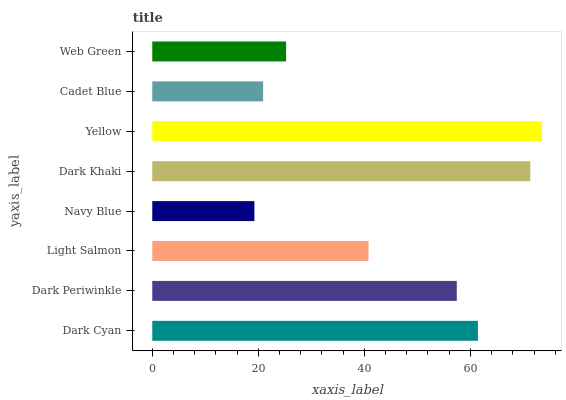Is Navy Blue the minimum?
Answer yes or no. Yes. Is Yellow the maximum?
Answer yes or no. Yes. Is Dark Periwinkle the minimum?
Answer yes or no. No. Is Dark Periwinkle the maximum?
Answer yes or no. No. Is Dark Cyan greater than Dark Periwinkle?
Answer yes or no. Yes. Is Dark Periwinkle less than Dark Cyan?
Answer yes or no. Yes. Is Dark Periwinkle greater than Dark Cyan?
Answer yes or no. No. Is Dark Cyan less than Dark Periwinkle?
Answer yes or no. No. Is Dark Periwinkle the high median?
Answer yes or no. Yes. Is Light Salmon the low median?
Answer yes or no. Yes. Is Navy Blue the high median?
Answer yes or no. No. Is Dark Periwinkle the low median?
Answer yes or no. No. 